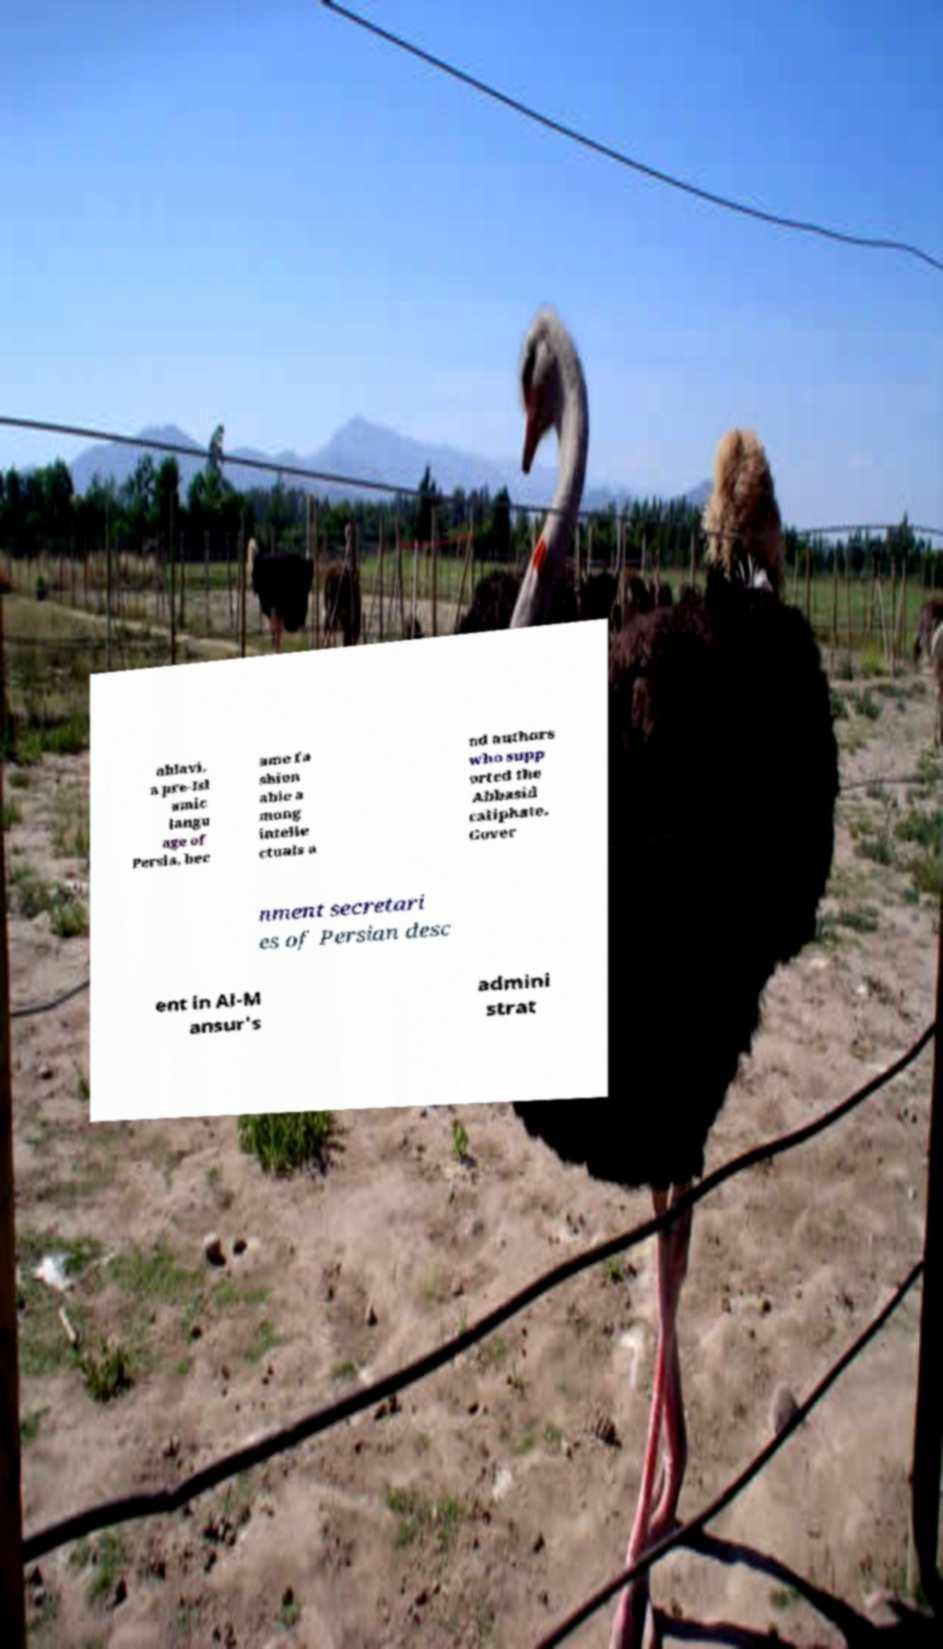What messages or text are displayed in this image? I need them in a readable, typed format. ahlavi, a pre-Isl amic langu age of Persia, bec ame fa shion able a mong intelle ctuals a nd authors who supp orted the Abbasid caliphate. Gover nment secretari es of Persian desc ent in Al-M ansur's admini strat 